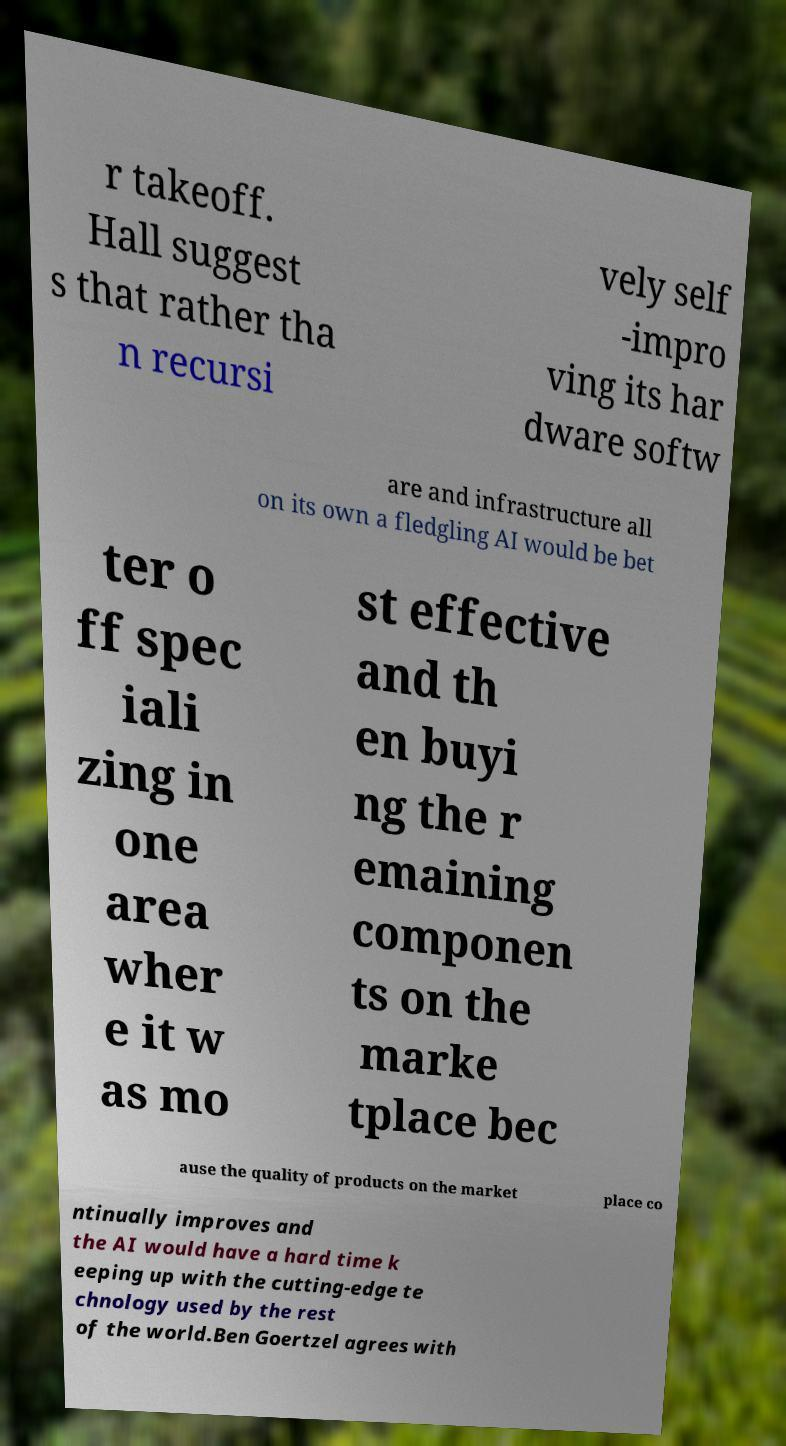What messages or text are displayed in this image? I need them in a readable, typed format. r takeoff. Hall suggest s that rather tha n recursi vely self -impro ving its har dware softw are and infrastructure all on its own a fledgling AI would be bet ter o ff spec iali zing in one area wher e it w as mo st effective and th en buyi ng the r emaining componen ts on the marke tplace bec ause the quality of products on the market place co ntinually improves and the AI would have a hard time k eeping up with the cutting-edge te chnology used by the rest of the world.Ben Goertzel agrees with 